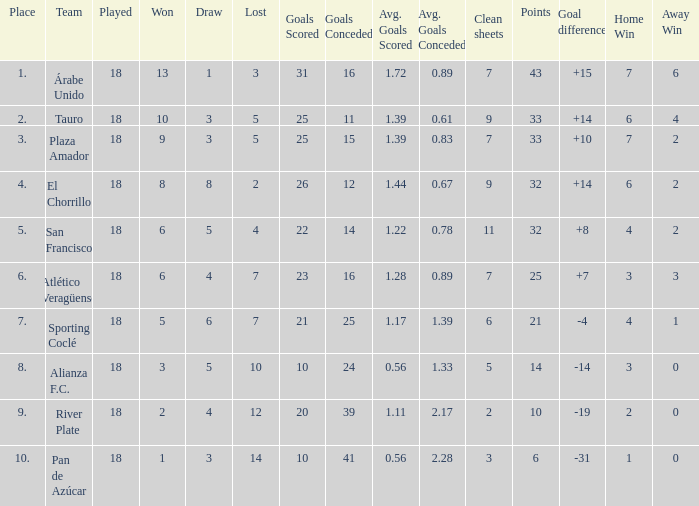How many goals were conceded by teams with 32 points, more than 2 losses and more than 22 goals scored? 0.0. 